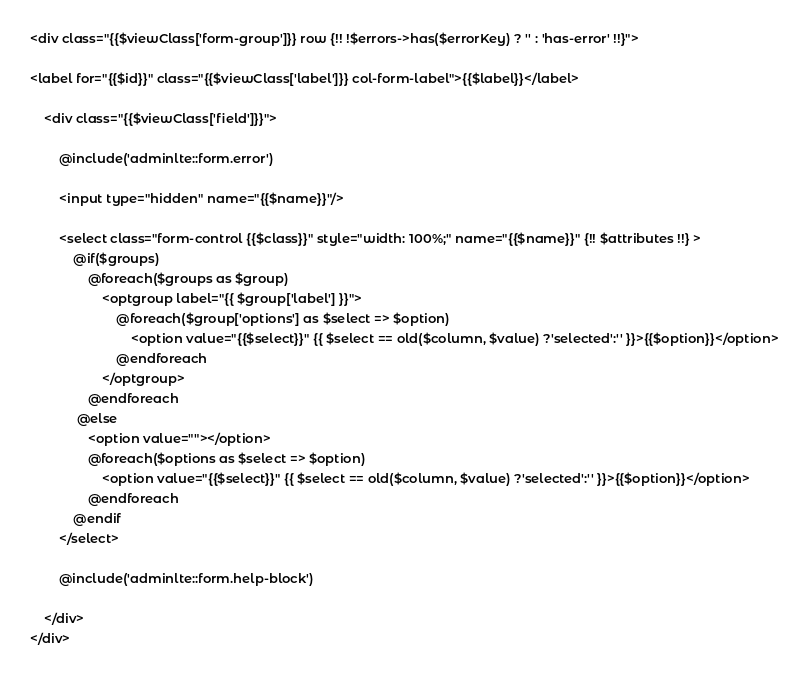Convert code to text. <code><loc_0><loc_0><loc_500><loc_500><_PHP_><div class="{{$viewClass['form-group']}} row {!! !$errors->has($errorKey) ? '' : 'has-error' !!}">

<label for="{{$id}}" class="{{$viewClass['label']}} col-form-label">{{$label}}</label>

    <div class="{{$viewClass['field']}}">

        @include('adminlte::form.error')

        <input type="hidden" name="{{$name}}"/>

        <select class="form-control {{$class}}" style="width: 100%;" name="{{$name}}" {!! $attributes !!} >
            @if($groups)
                @foreach($groups as $group)
                    <optgroup label="{{ $group['label'] }}">
                        @foreach($group['options'] as $select => $option)
                            <option value="{{$select}}" {{ $select == old($column, $value) ?'selected':'' }}>{{$option}}</option>
                        @endforeach
                    </optgroup>
                @endforeach
             @else
                <option value=""></option>
                @foreach($options as $select => $option)
                    <option value="{{$select}}" {{ $select == old($column, $value) ?'selected':'' }}>{{$option}}</option>
                @endforeach
            @endif
        </select>

        @include('adminlte::form.help-block')

    </div>
</div>
</code> 